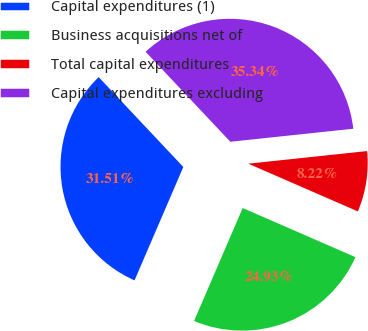<chart> <loc_0><loc_0><loc_500><loc_500><pie_chart><fcel>Capital expenditures (1)<fcel>Business acquisitions net of<fcel>Total capital expenditures<fcel>Capital expenditures excluding<nl><fcel>31.51%<fcel>24.93%<fcel>8.22%<fcel>35.34%<nl></chart> 